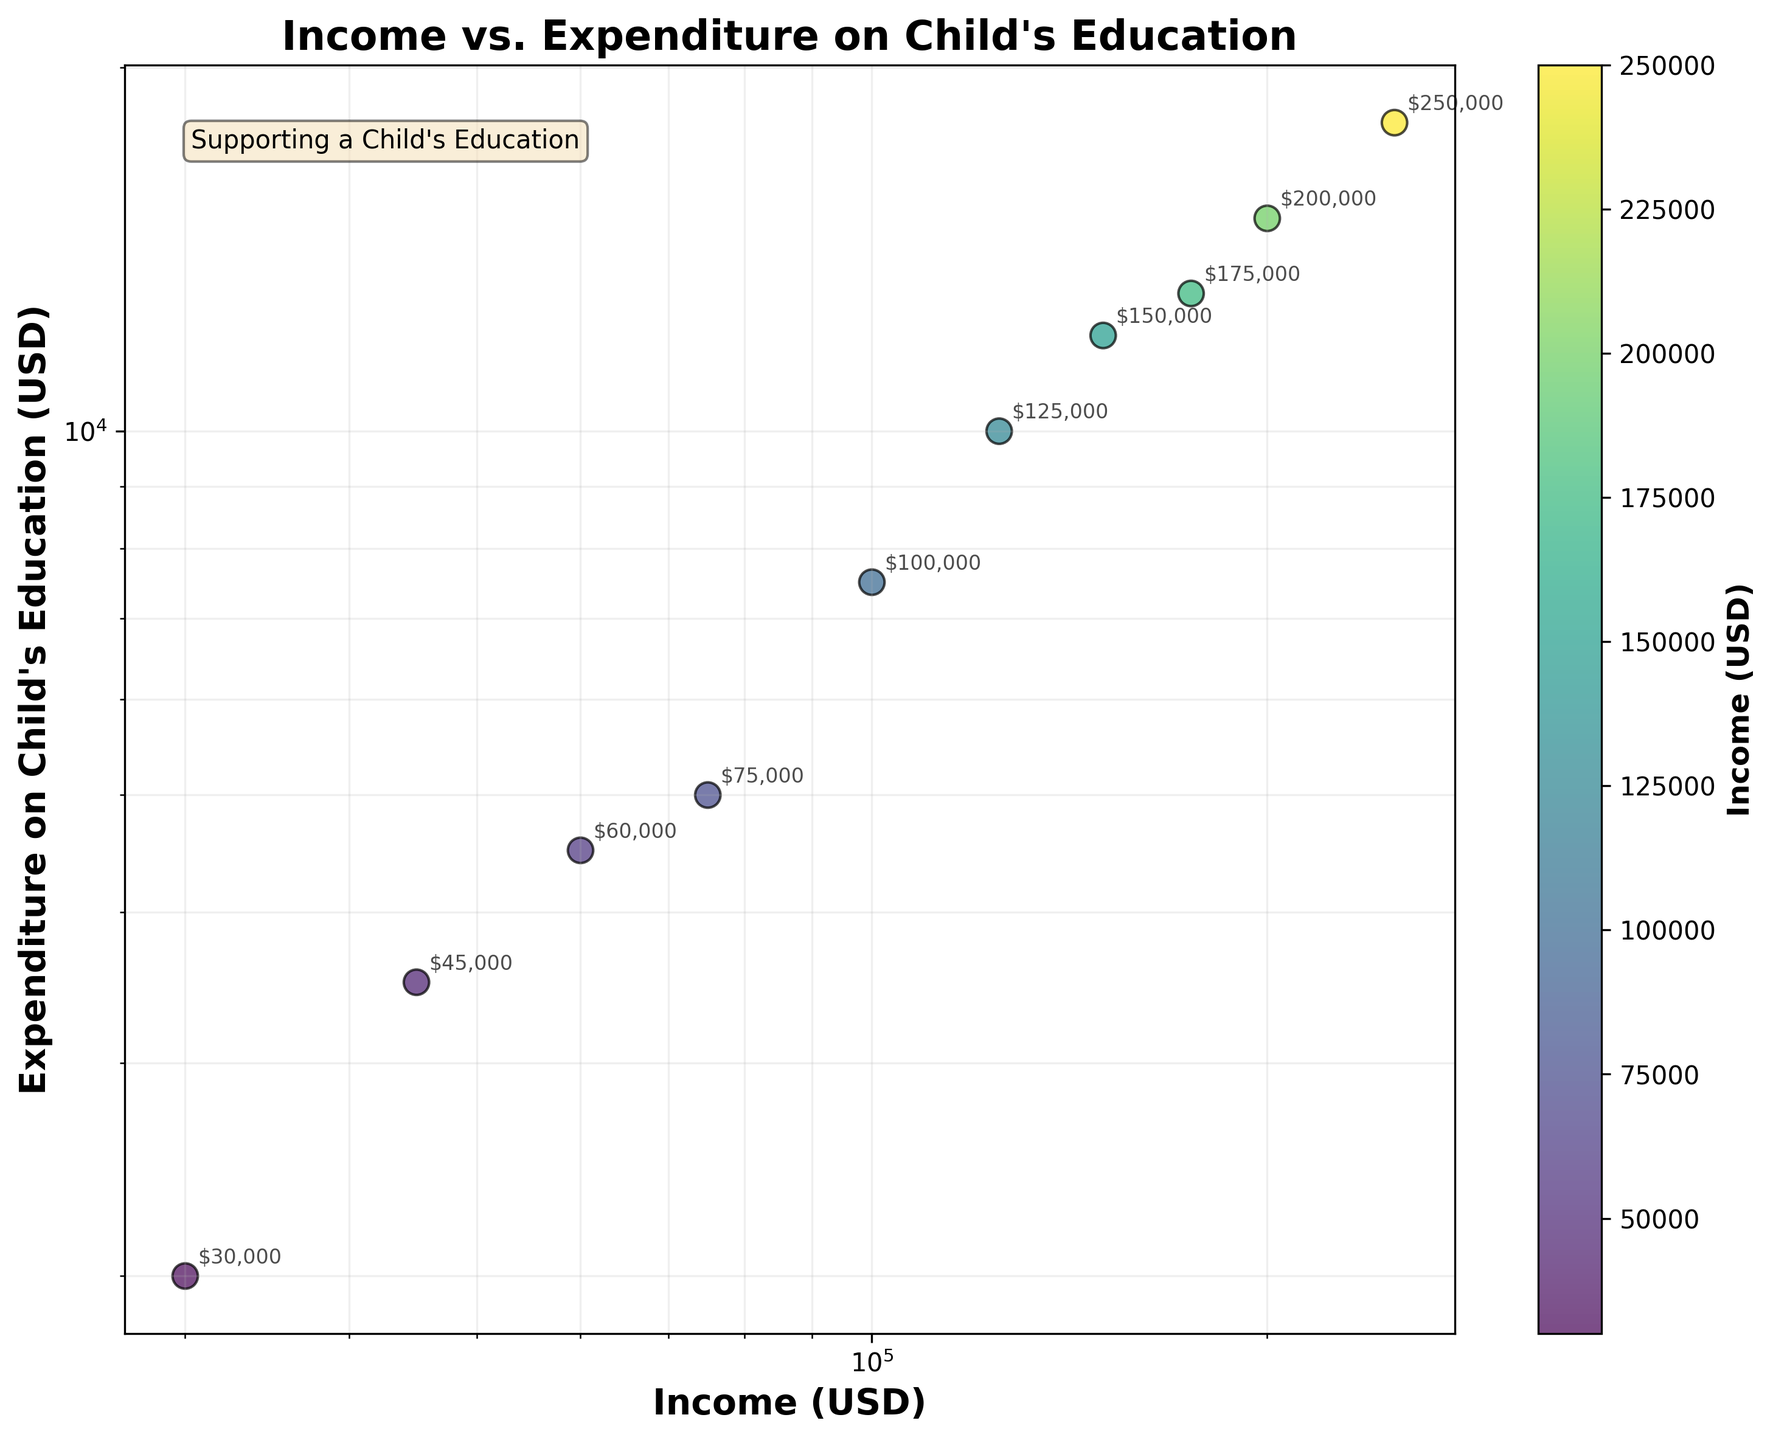How many data points are there in the scatter plot? The scatter plot has markers for each data point. Count the number of markers.
Answer: 10 What is the title of the scatter plot? The title of the scatter plot is displayed at the top of the chart.
Answer: Income vs. Expenditure on Child's Education What is the minimum expenditure on child's education depicted in the plot? Examine the y-axis values and identify the lowest value.
Answer: $2,000 Which household has the highest income, and what is their expenditure on child's education? The household with the highest income will be farthest to the right on the x-axis. Look at the corresponding y-axis value for their expenditure.
Answer: $250,000 and $18,000 What is the general trend between income and expenditure on child's education? Observe the pattern of the data points. Higher income households tend to be higher on the plot, indicating a positive trend.
Answer: Positive correlation What is the income of the household spending $10,000 on a child's education? Identify the data point corresponding to an expenditure of $10,000 on the y-axis and find the associated x-axis value.
Answer: $125,000 Is there any household with an income below $50,000? Check the x-axis values to see if there are any data points on or below the $50,000 mark.
Answer: Yes Compare the expenditure on child's education between households with an income of $60,000 and $150,000. Locate the data points for households earning $60,000 and $150,000 and compare their y-axis values.
Answer: $4,500 and $12,000 Is there a linear or non-linear relationship depicted in the scatter plot? The log scale can reveal if the points align in a straight line or curve. Examine the pattern of the points.
Answer: Non-linear relationship What is the color scheme used for the data points in the scatter plot? The plot utilizes a colormap for the data points. Identify the colormap used.
Answer: Viridis 